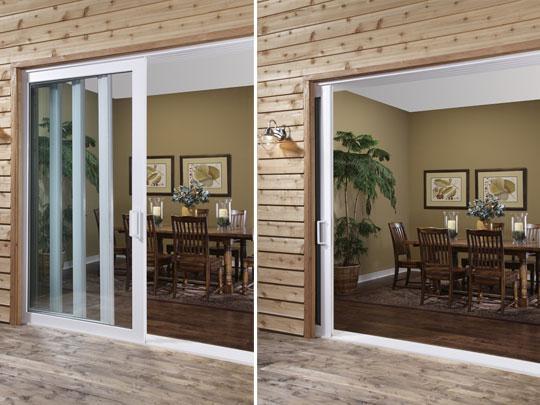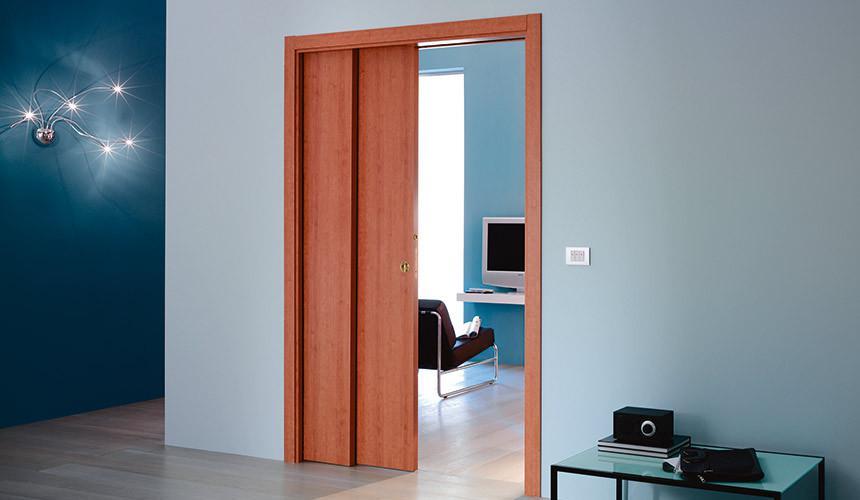The first image is the image on the left, the second image is the image on the right. Analyze the images presented: Is the assertion "In at least one image there is an open white and glass panel door that shows chairs behind it." valid? Answer yes or no. Yes. The first image is the image on the left, the second image is the image on the right. Examine the images to the left and right. Is the description "A set of doors opens to a dark colored table in the image ont he left." accurate? Answer yes or no. Yes. 